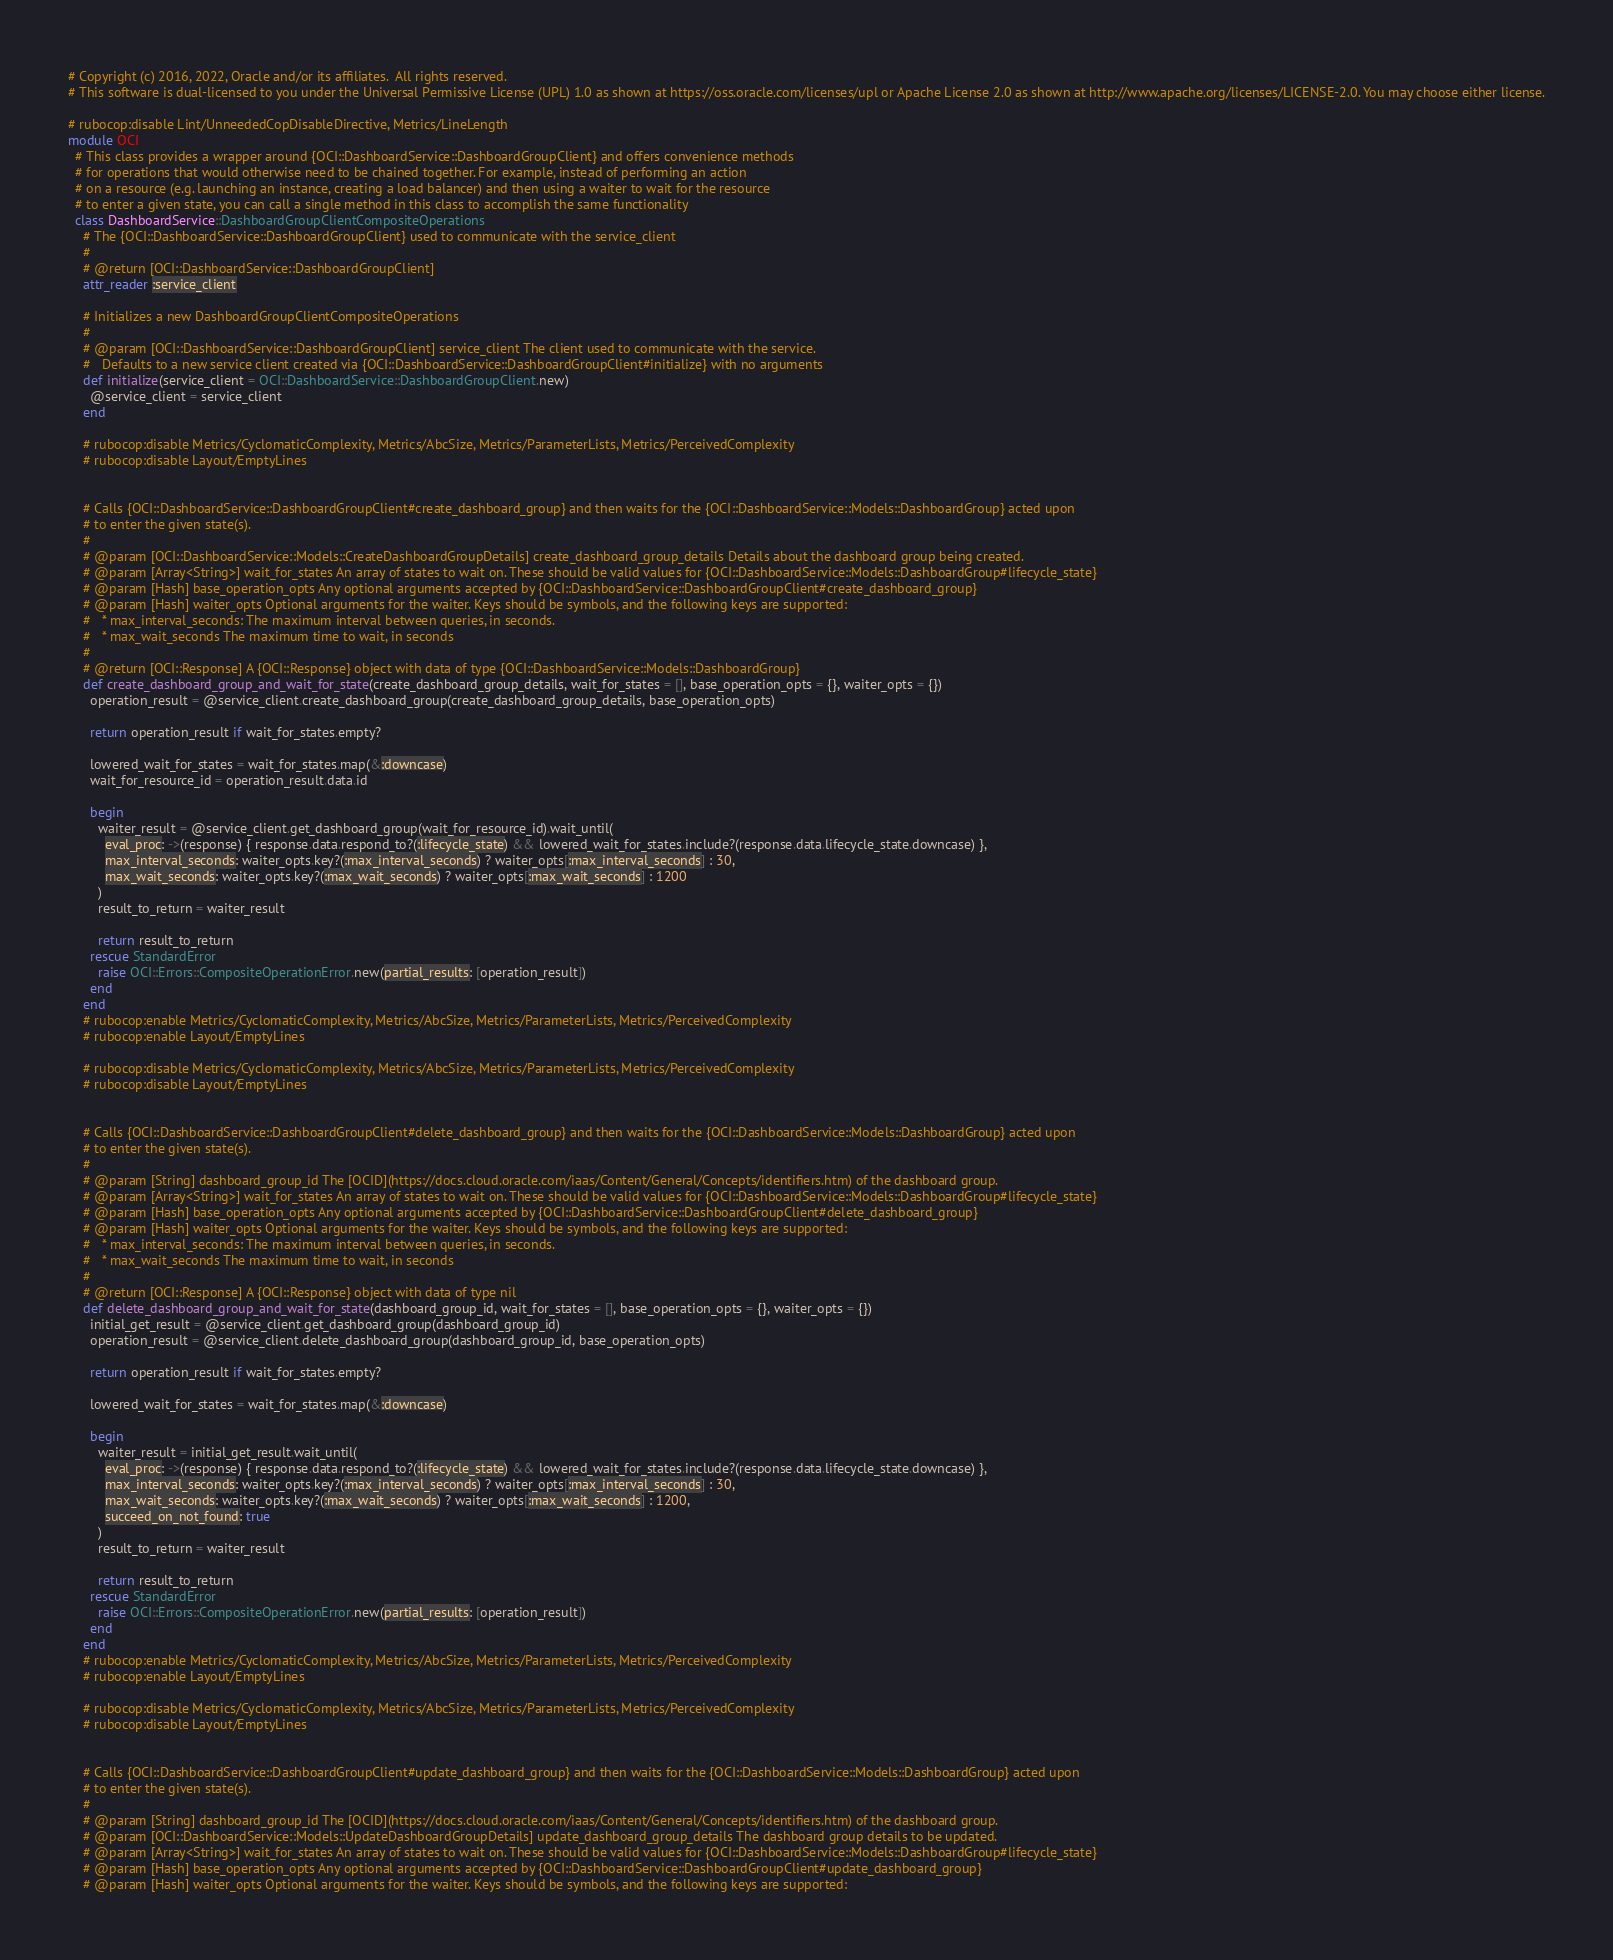Convert code to text. <code><loc_0><loc_0><loc_500><loc_500><_Ruby_># Copyright (c) 2016, 2022, Oracle and/or its affiliates.  All rights reserved.
# This software is dual-licensed to you under the Universal Permissive License (UPL) 1.0 as shown at https://oss.oracle.com/licenses/upl or Apache License 2.0 as shown at http://www.apache.org/licenses/LICENSE-2.0. You may choose either license.

# rubocop:disable Lint/UnneededCopDisableDirective, Metrics/LineLength
module OCI
  # This class provides a wrapper around {OCI::DashboardService::DashboardGroupClient} and offers convenience methods
  # for operations that would otherwise need to be chained together. For example, instead of performing an action
  # on a resource (e.g. launching an instance, creating a load balancer) and then using a waiter to wait for the resource
  # to enter a given state, you can call a single method in this class to accomplish the same functionality
  class DashboardService::DashboardGroupClientCompositeOperations
    # The {OCI::DashboardService::DashboardGroupClient} used to communicate with the service_client
    #
    # @return [OCI::DashboardService::DashboardGroupClient]
    attr_reader :service_client

    # Initializes a new DashboardGroupClientCompositeOperations
    #
    # @param [OCI::DashboardService::DashboardGroupClient] service_client The client used to communicate with the service.
    #   Defaults to a new service client created via {OCI::DashboardService::DashboardGroupClient#initialize} with no arguments
    def initialize(service_client = OCI::DashboardService::DashboardGroupClient.new)
      @service_client = service_client
    end

    # rubocop:disable Metrics/CyclomaticComplexity, Metrics/AbcSize, Metrics/ParameterLists, Metrics/PerceivedComplexity
    # rubocop:disable Layout/EmptyLines


    # Calls {OCI::DashboardService::DashboardGroupClient#create_dashboard_group} and then waits for the {OCI::DashboardService::Models::DashboardGroup} acted upon
    # to enter the given state(s).
    #
    # @param [OCI::DashboardService::Models::CreateDashboardGroupDetails] create_dashboard_group_details Details about the dashboard group being created.
    # @param [Array<String>] wait_for_states An array of states to wait on. These should be valid values for {OCI::DashboardService::Models::DashboardGroup#lifecycle_state}
    # @param [Hash] base_operation_opts Any optional arguments accepted by {OCI::DashboardService::DashboardGroupClient#create_dashboard_group}
    # @param [Hash] waiter_opts Optional arguments for the waiter. Keys should be symbols, and the following keys are supported:
    #   * max_interval_seconds: The maximum interval between queries, in seconds.
    #   * max_wait_seconds The maximum time to wait, in seconds
    #
    # @return [OCI::Response] A {OCI::Response} object with data of type {OCI::DashboardService::Models::DashboardGroup}
    def create_dashboard_group_and_wait_for_state(create_dashboard_group_details, wait_for_states = [], base_operation_opts = {}, waiter_opts = {})
      operation_result = @service_client.create_dashboard_group(create_dashboard_group_details, base_operation_opts)

      return operation_result if wait_for_states.empty?

      lowered_wait_for_states = wait_for_states.map(&:downcase)
      wait_for_resource_id = operation_result.data.id

      begin
        waiter_result = @service_client.get_dashboard_group(wait_for_resource_id).wait_until(
          eval_proc: ->(response) { response.data.respond_to?(:lifecycle_state) && lowered_wait_for_states.include?(response.data.lifecycle_state.downcase) },
          max_interval_seconds: waiter_opts.key?(:max_interval_seconds) ? waiter_opts[:max_interval_seconds] : 30,
          max_wait_seconds: waiter_opts.key?(:max_wait_seconds) ? waiter_opts[:max_wait_seconds] : 1200
        )
        result_to_return = waiter_result

        return result_to_return
      rescue StandardError
        raise OCI::Errors::CompositeOperationError.new(partial_results: [operation_result])
      end
    end
    # rubocop:enable Metrics/CyclomaticComplexity, Metrics/AbcSize, Metrics/ParameterLists, Metrics/PerceivedComplexity
    # rubocop:enable Layout/EmptyLines

    # rubocop:disable Metrics/CyclomaticComplexity, Metrics/AbcSize, Metrics/ParameterLists, Metrics/PerceivedComplexity
    # rubocop:disable Layout/EmptyLines


    # Calls {OCI::DashboardService::DashboardGroupClient#delete_dashboard_group} and then waits for the {OCI::DashboardService::Models::DashboardGroup} acted upon
    # to enter the given state(s).
    #
    # @param [String] dashboard_group_id The [OCID](https://docs.cloud.oracle.com/iaas/Content/General/Concepts/identifiers.htm) of the dashboard group.
    # @param [Array<String>] wait_for_states An array of states to wait on. These should be valid values for {OCI::DashboardService::Models::DashboardGroup#lifecycle_state}
    # @param [Hash] base_operation_opts Any optional arguments accepted by {OCI::DashboardService::DashboardGroupClient#delete_dashboard_group}
    # @param [Hash] waiter_opts Optional arguments for the waiter. Keys should be symbols, and the following keys are supported:
    #   * max_interval_seconds: The maximum interval between queries, in seconds.
    #   * max_wait_seconds The maximum time to wait, in seconds
    #
    # @return [OCI::Response] A {OCI::Response} object with data of type nil
    def delete_dashboard_group_and_wait_for_state(dashboard_group_id, wait_for_states = [], base_operation_opts = {}, waiter_opts = {})
      initial_get_result = @service_client.get_dashboard_group(dashboard_group_id)
      operation_result = @service_client.delete_dashboard_group(dashboard_group_id, base_operation_opts)

      return operation_result if wait_for_states.empty?

      lowered_wait_for_states = wait_for_states.map(&:downcase)

      begin
        waiter_result = initial_get_result.wait_until(
          eval_proc: ->(response) { response.data.respond_to?(:lifecycle_state) && lowered_wait_for_states.include?(response.data.lifecycle_state.downcase) },
          max_interval_seconds: waiter_opts.key?(:max_interval_seconds) ? waiter_opts[:max_interval_seconds] : 30,
          max_wait_seconds: waiter_opts.key?(:max_wait_seconds) ? waiter_opts[:max_wait_seconds] : 1200,
          succeed_on_not_found: true
        )
        result_to_return = waiter_result

        return result_to_return
      rescue StandardError
        raise OCI::Errors::CompositeOperationError.new(partial_results: [operation_result])
      end
    end
    # rubocop:enable Metrics/CyclomaticComplexity, Metrics/AbcSize, Metrics/ParameterLists, Metrics/PerceivedComplexity
    # rubocop:enable Layout/EmptyLines

    # rubocop:disable Metrics/CyclomaticComplexity, Metrics/AbcSize, Metrics/ParameterLists, Metrics/PerceivedComplexity
    # rubocop:disable Layout/EmptyLines


    # Calls {OCI::DashboardService::DashboardGroupClient#update_dashboard_group} and then waits for the {OCI::DashboardService::Models::DashboardGroup} acted upon
    # to enter the given state(s).
    #
    # @param [String] dashboard_group_id The [OCID](https://docs.cloud.oracle.com/iaas/Content/General/Concepts/identifiers.htm) of the dashboard group.
    # @param [OCI::DashboardService::Models::UpdateDashboardGroupDetails] update_dashboard_group_details The dashboard group details to be updated.
    # @param [Array<String>] wait_for_states An array of states to wait on. These should be valid values for {OCI::DashboardService::Models::DashboardGroup#lifecycle_state}
    # @param [Hash] base_operation_opts Any optional arguments accepted by {OCI::DashboardService::DashboardGroupClient#update_dashboard_group}
    # @param [Hash] waiter_opts Optional arguments for the waiter. Keys should be symbols, and the following keys are supported:</code> 